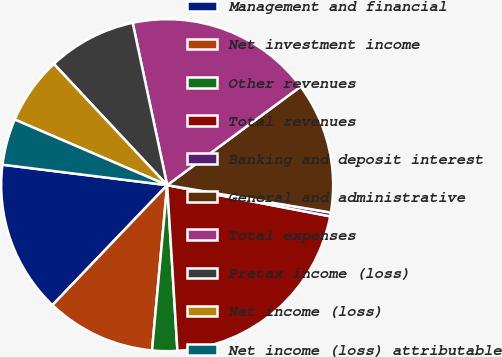Convert chart. <chart><loc_0><loc_0><loc_500><loc_500><pie_chart><fcel>Management and financial<fcel>Net investment income<fcel>Other revenues<fcel>Total revenues<fcel>Banking and deposit interest<fcel>General and administrative<fcel>Total expenses<fcel>Pretax income (loss)<fcel>Net income (loss)<fcel>Net income (loss) attributable<nl><fcel>14.82%<fcel>10.69%<fcel>2.44%<fcel>21.01%<fcel>0.37%<fcel>12.76%<fcel>18.21%<fcel>8.63%<fcel>6.57%<fcel>4.5%<nl></chart> 